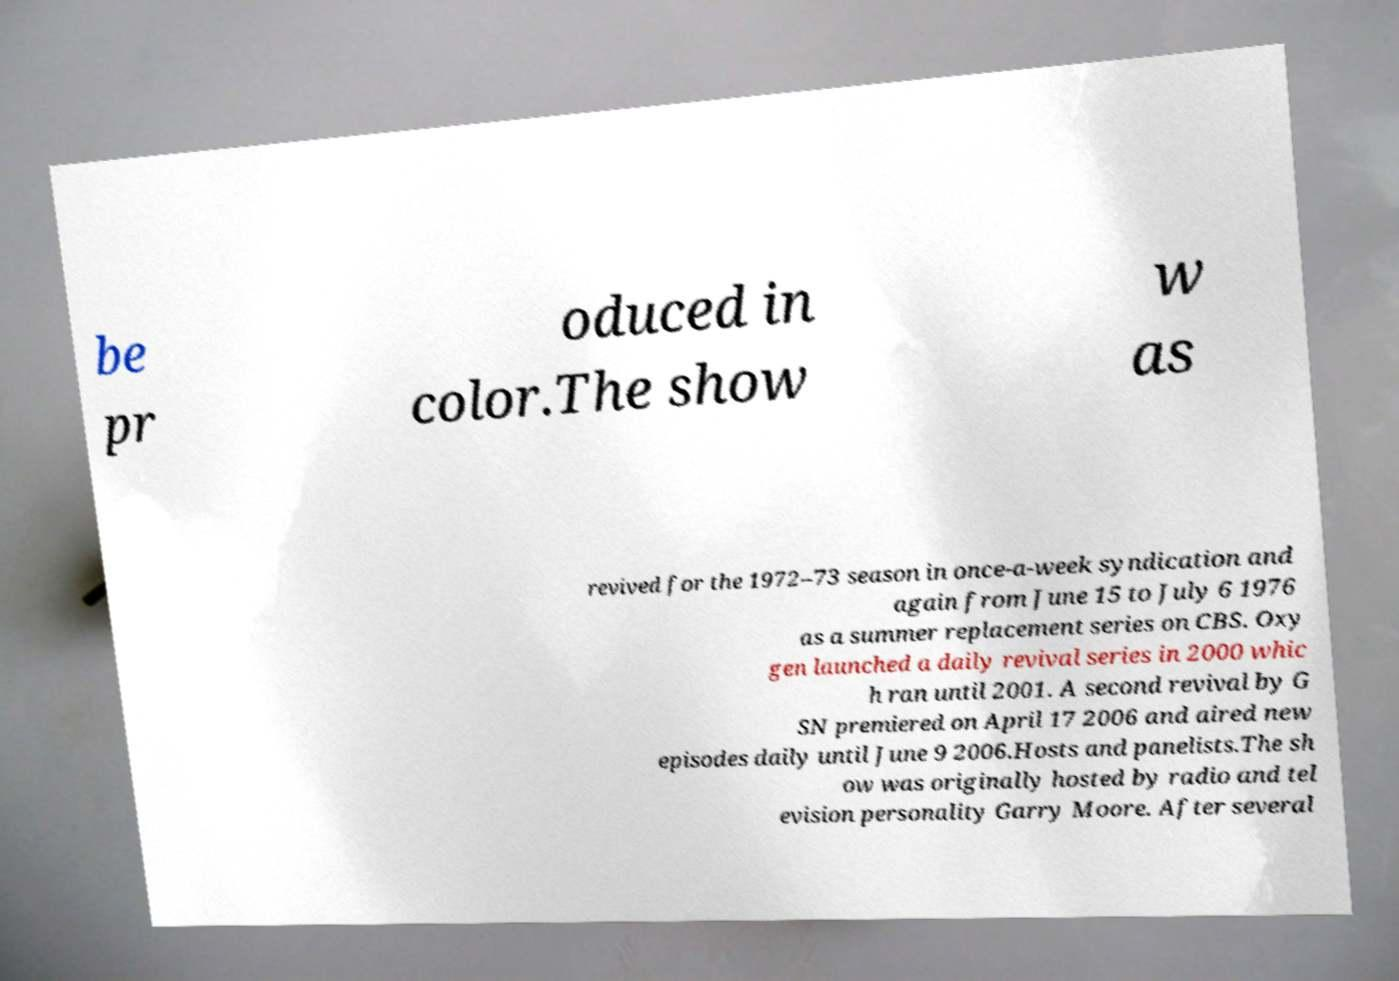Can you accurately transcribe the text from the provided image for me? be pr oduced in color.The show w as revived for the 1972–73 season in once-a-week syndication and again from June 15 to July 6 1976 as a summer replacement series on CBS. Oxy gen launched a daily revival series in 2000 whic h ran until 2001. A second revival by G SN premiered on April 17 2006 and aired new episodes daily until June 9 2006.Hosts and panelists.The sh ow was originally hosted by radio and tel evision personality Garry Moore. After several 